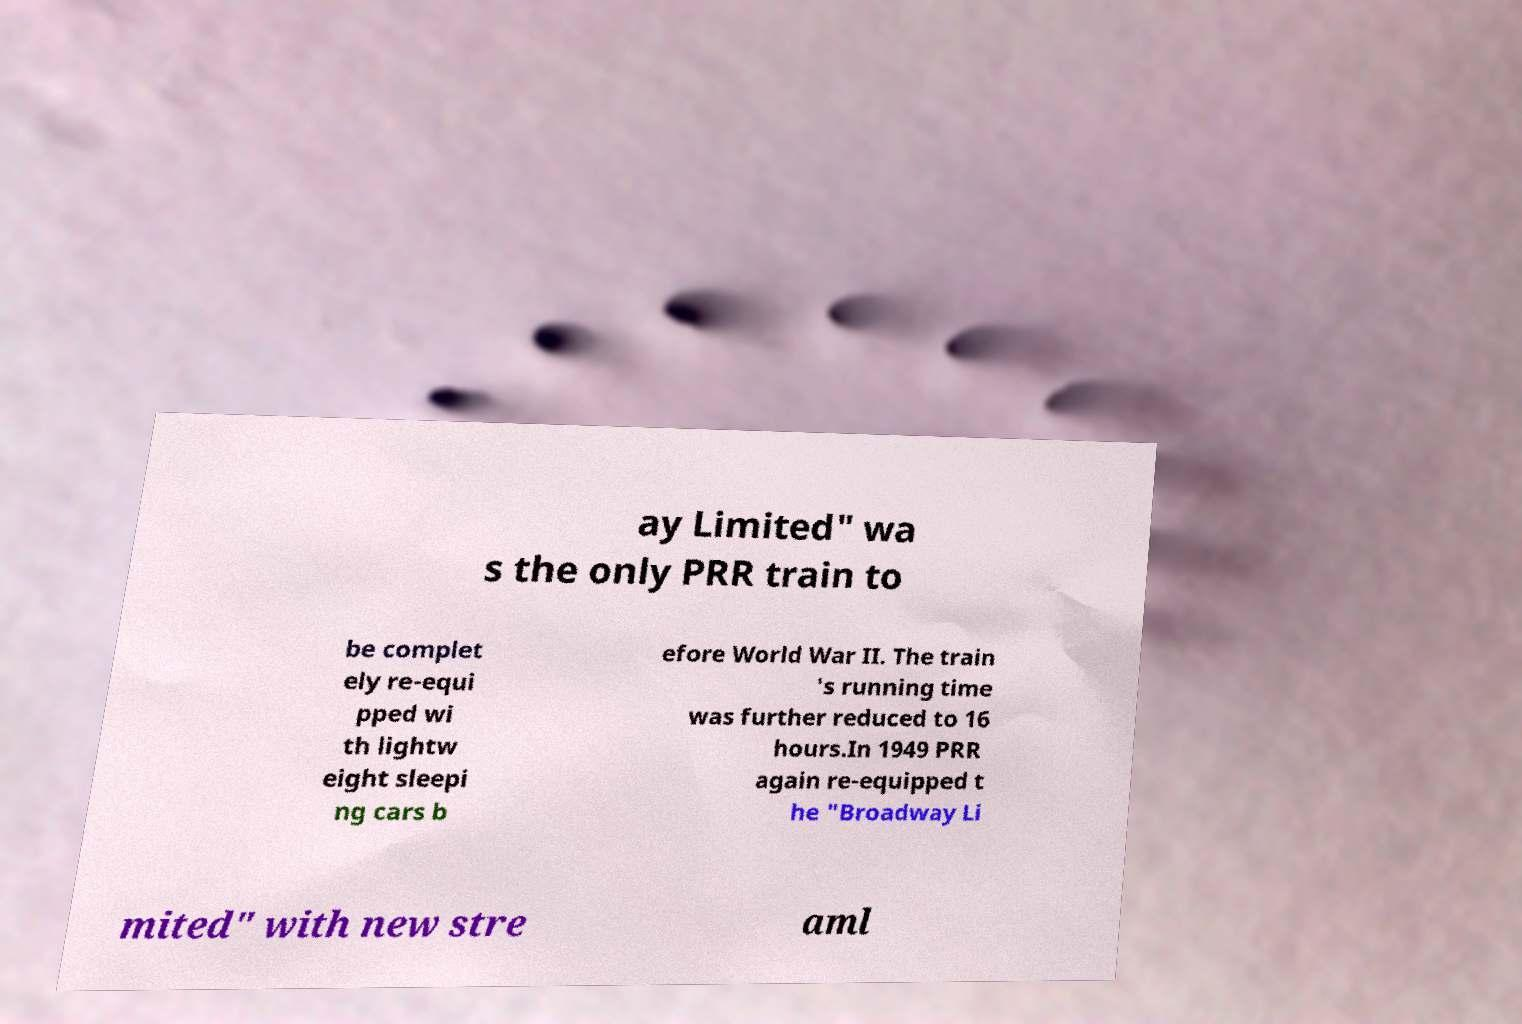Could you extract and type out the text from this image? ay Limited" wa s the only PRR train to be complet ely re-equi pped wi th lightw eight sleepi ng cars b efore World War II. The train 's running time was further reduced to 16 hours.In 1949 PRR again re-equipped t he "Broadway Li mited" with new stre aml 